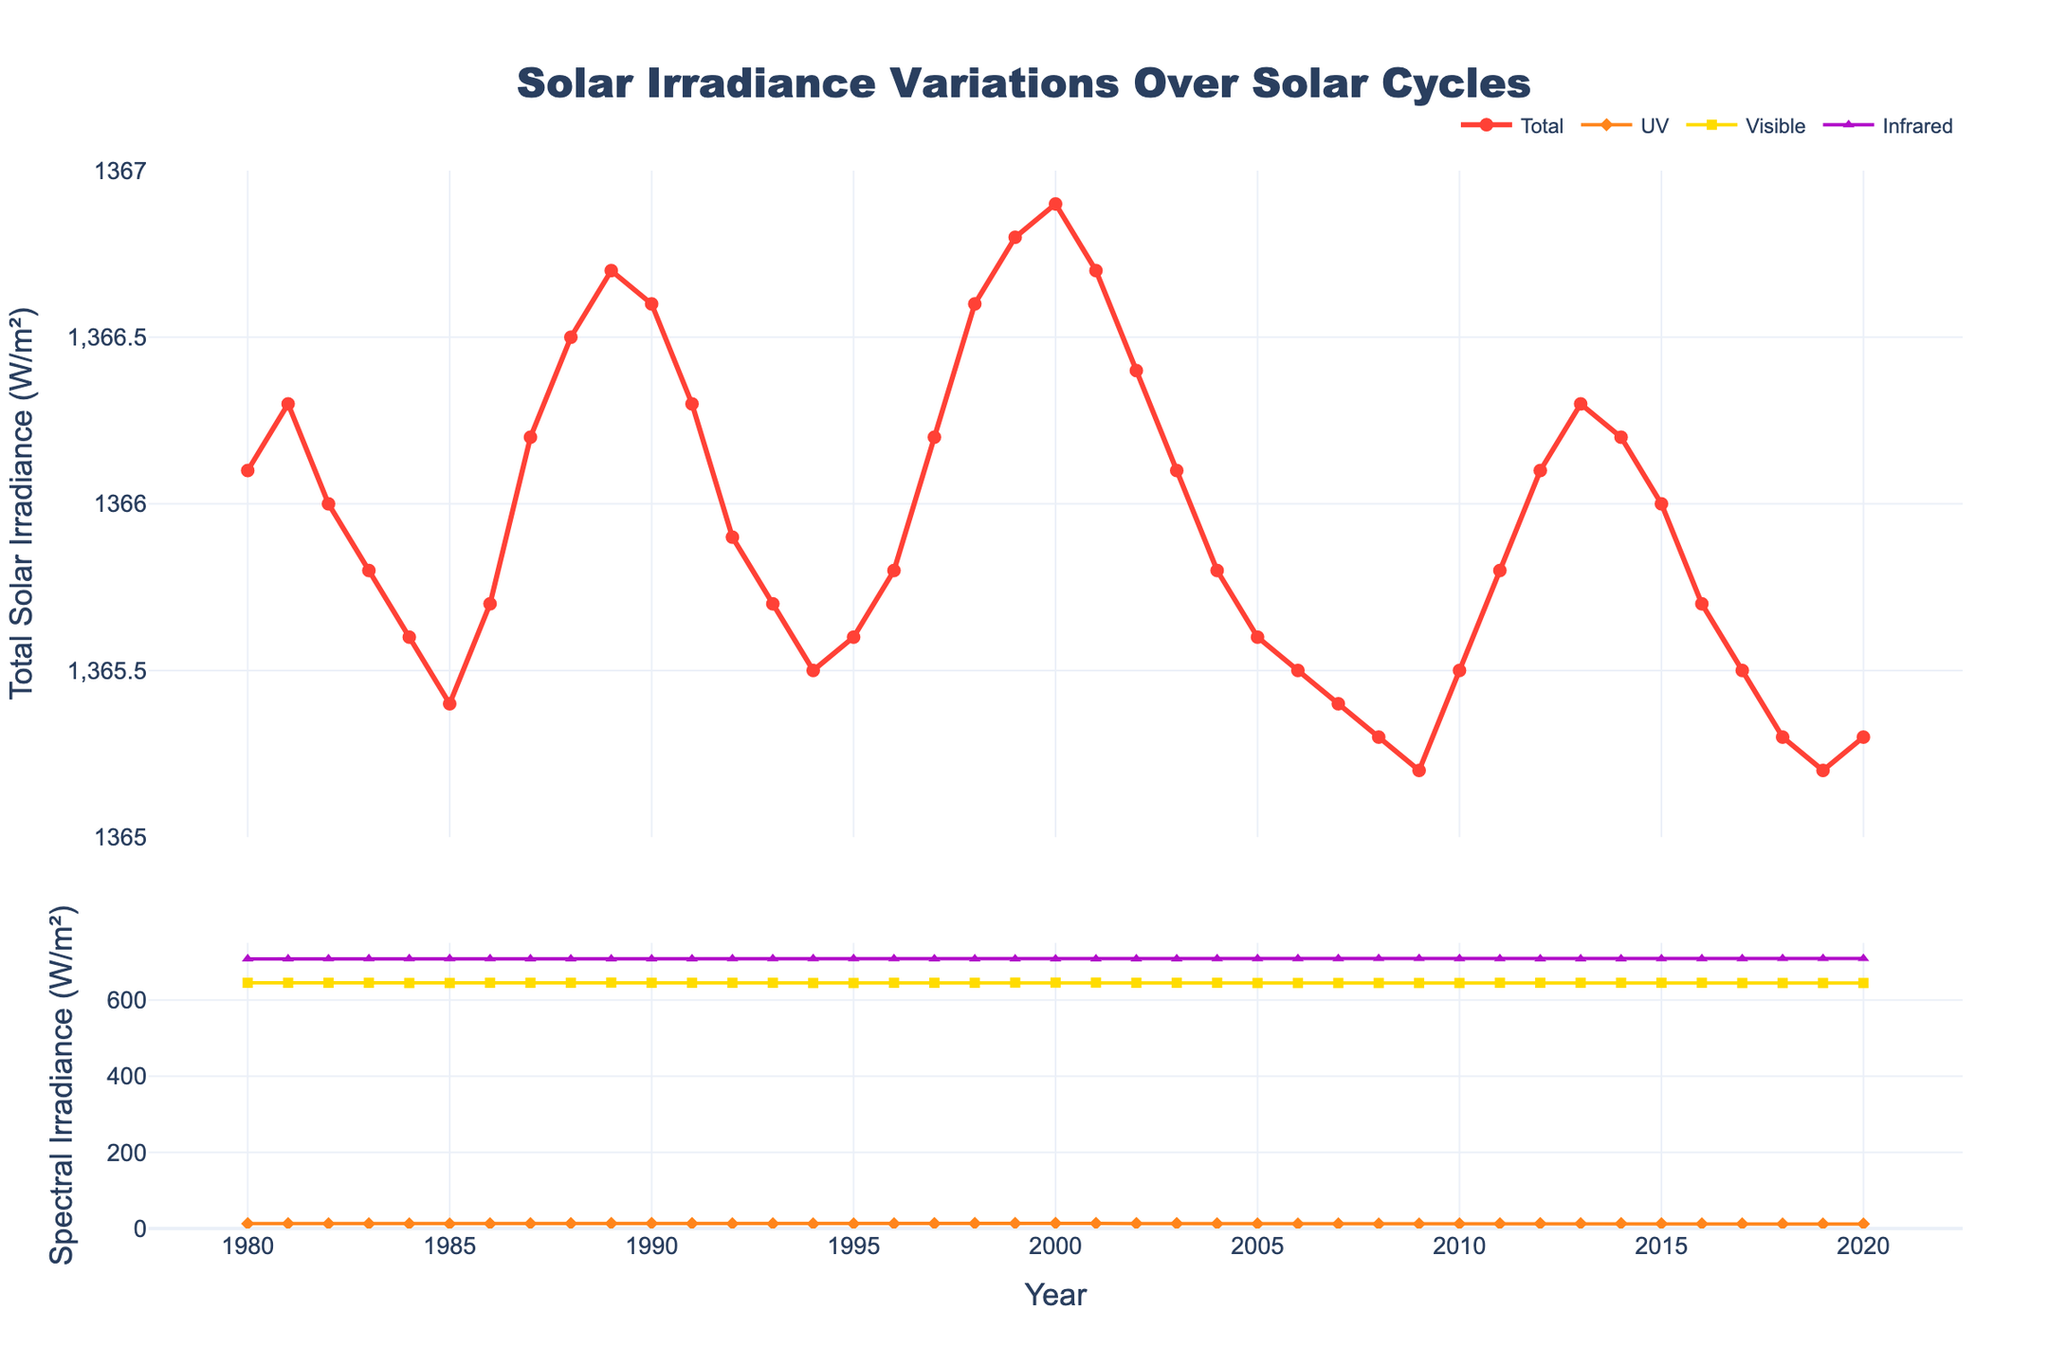Which year has the highest total solar irradiance? The highest point in the total solar irradiance plot corresponds to the year 2000.
Answer: 2000 What is the approximate difference in UV irradiance between the years 1980 and 2000? The UV irradiance for 1980 is about 12.8 W/m², and for 2000, it is 13.6 W/m². The difference is 13.6 - 12.8 = 0.8 W/m².
Answer: 0.8 W/m² Which type of irradiance shows the least variation over the years? Visible irradiance shows the least variation as its line remains relatively flat compared to others.
Answer: Visible irradiance What is the trend of infrared irradiance from 1980 to 2020? Infrared irradiance shows a decreasing trend from 708.1 W/m² in 1980 to 708.8 W/m² in 2020, with some fluctuations.
Answer: Decreasing How does the UV irradiance in 1987 compare to that in 1996? UV irradiance in 1987 is 12.9 W/m², while it is 12.5 W/m² in 1996. So, UV irradiance in 1987 is higher.
Answer: Higher What is the correlation between total solar irradiance and visible irradiance? Both values show very similar trends and fluctuations, indicating a strong correlation between total solar irradiance and visible irradiance.
Answer: Strong correlation Calculate the average total solar irradiance over the first decade (1980-1989). Sum of total solar irradiance from 1980 to 1989: 1366.1 + 1366.3 + 1366.0 + 1365.8 + 1365.6 + 1365.4 + 1365.7 + 1366.2 + 1366.5 + 1366.7 = 13660.3 W/m². The average is 13660.3 / 10 = 1366.03 W/m².
Answer: 1366.03 W/m² Which spectral component shows five peaks over the given period? UV irradiance has five noticeable peaks over the given period, as indicated by the distinct upward spikes.
Answer: UV irradiance How does the trend of visible irradiance from 1990 to 2020 compare with UV irradiance in the same period? Both visible and UV irradiance show similar upward and downward trends; however, UV irradiance has more pronounced peaks and valleys.
Answer: Similar trend What is the approximate total sum of infrared irradiance from 2008 to 2010? Sum of infrared irradiance: 708.8 (2008) + 708.9 (2009) + 708.6 (2010) = 2126.3 W/m².
Answer: 2126.3 W/m² 